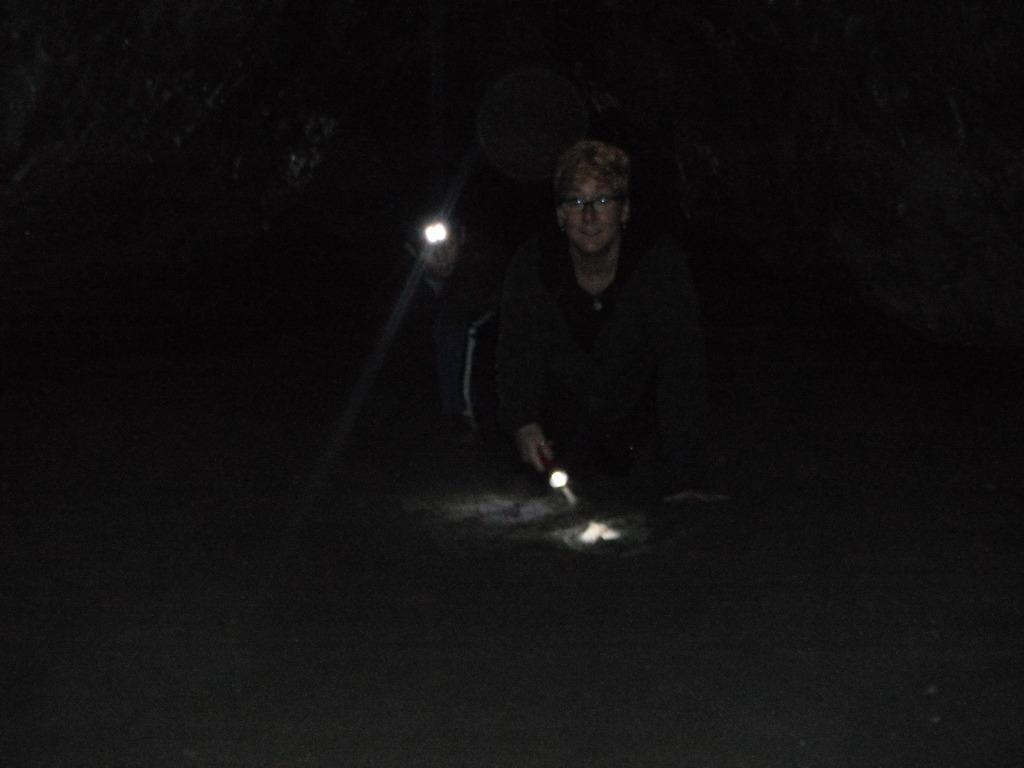Could you give a brief overview of what you see in this image? In this picture I can see 2 persons, who are holding lights and I see that this picture is in dark. 